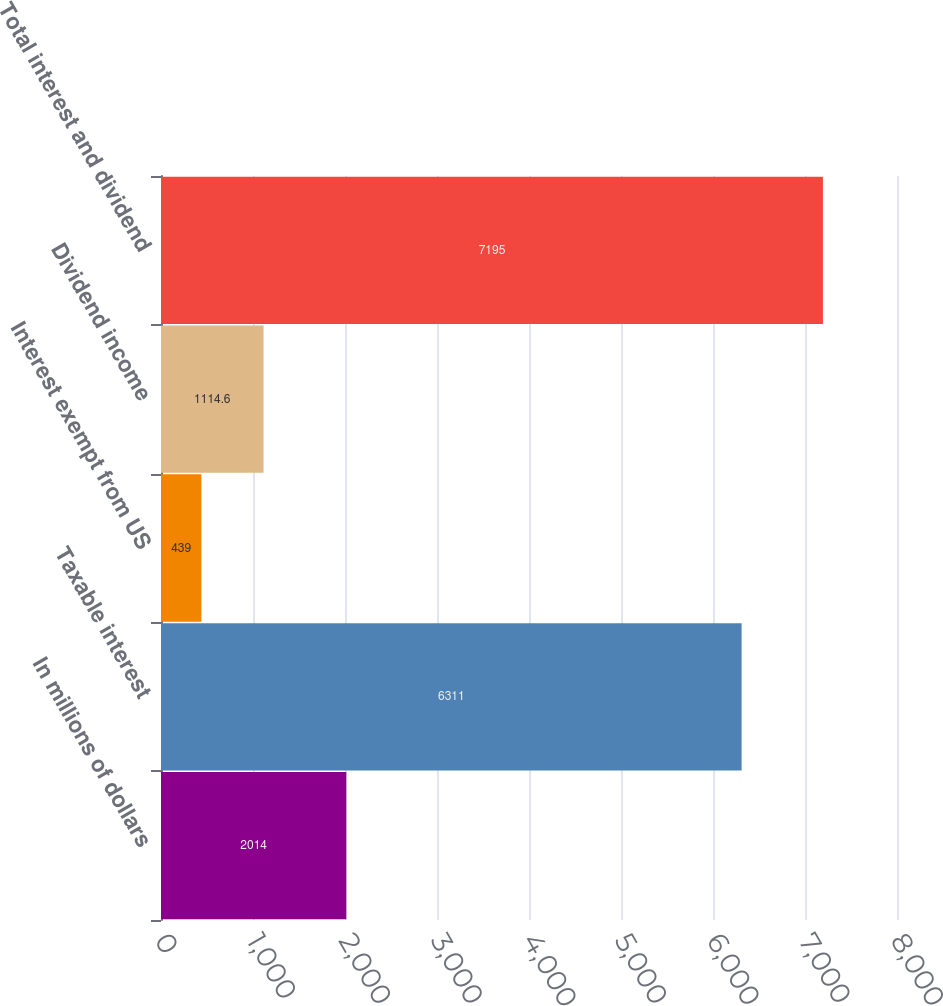Convert chart to OTSL. <chart><loc_0><loc_0><loc_500><loc_500><bar_chart><fcel>In millions of dollars<fcel>Taxable interest<fcel>Interest exempt from US<fcel>Dividend income<fcel>Total interest and dividend<nl><fcel>2014<fcel>6311<fcel>439<fcel>1114.6<fcel>7195<nl></chart> 